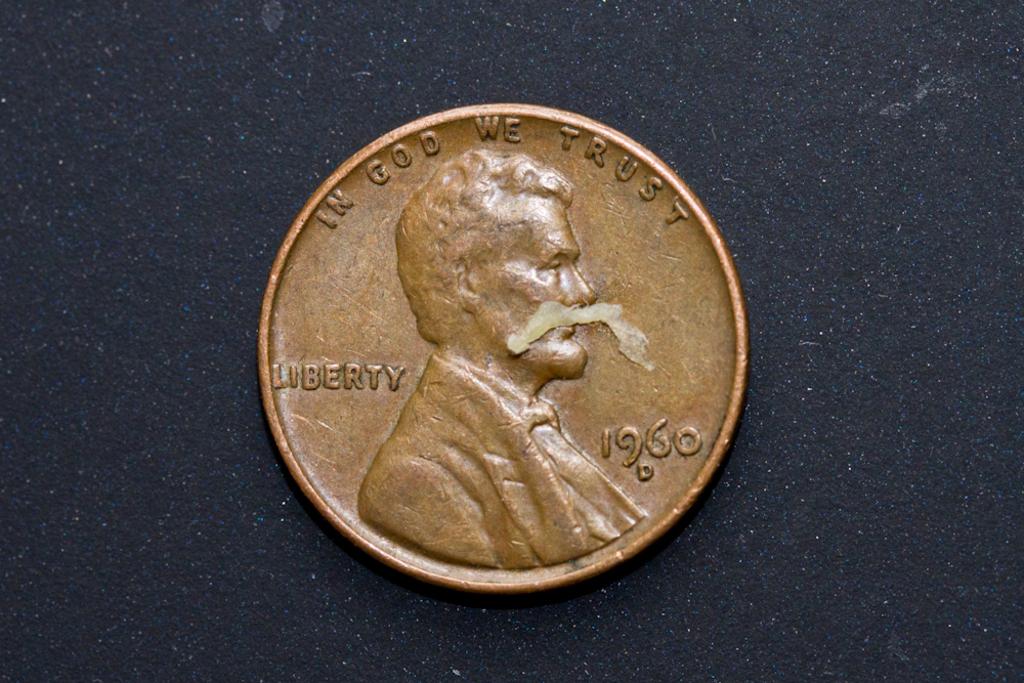What year is the penny from?
Offer a very short reply. 1960. What does the penny say we should trust?
Offer a very short reply. God. 